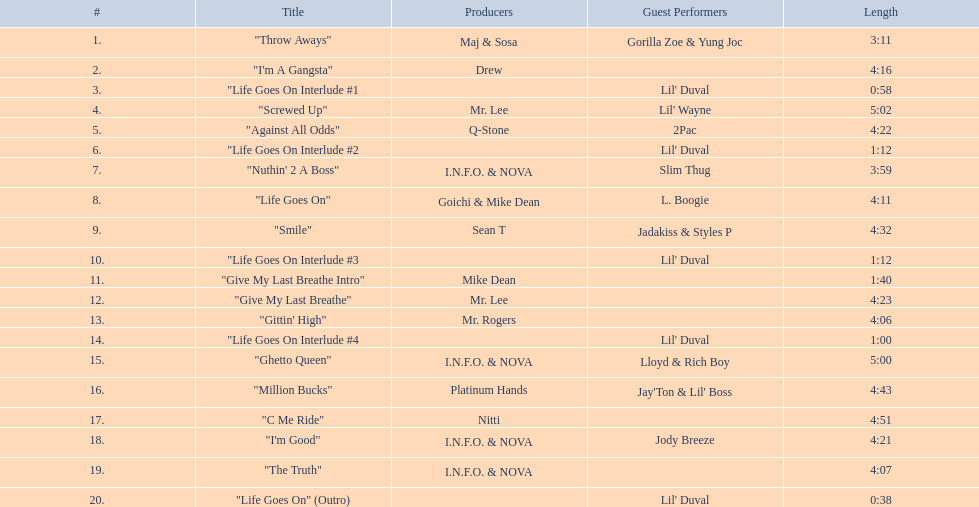Which tracks are longer than 4.00? "I'm A Gangsta", "Screwed Up", "Against All Odds", "Life Goes On", "Smile", "Give My Last Breathe", "Gittin' High", "Ghetto Queen", "Million Bucks", "C Me Ride", "I'm Good", "The Truth". Of those, which tracks are longer than 4.30? "Screwed Up", "Smile", "Ghetto Queen", "Million Bucks", "C Me Ride". Of those, which tracks are 5.00 or longer? "Screwed Up", "Ghetto Queen". Of those, which one is the longest? "Screwed Up". How long is that track? 5:02. 